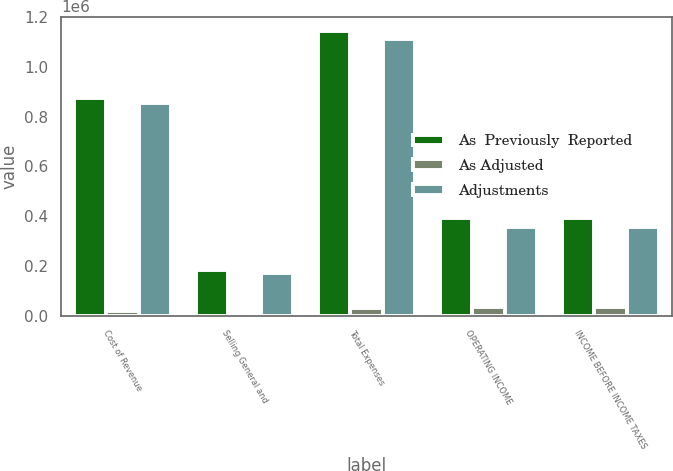Convert chart to OTSL. <chart><loc_0><loc_0><loc_500><loc_500><stacked_bar_chart><ecel><fcel>Cost of Revenue<fcel>Selling General and<fcel>Total Expenses<fcel>OPERATING INCOME<fcel>INCOME BEFORE INCOME TAXES<nl><fcel>As  Previously  Reported<fcel>873642<fcel>182146<fcel>1.14423e+06<fcel>392369<fcel>391024<nl><fcel>As Adjusted<fcel>20504<fcel>10436<fcel>30940<fcel>34866<fcel>34866<nl><fcel>Adjustments<fcel>853138<fcel>171710<fcel>1.11329e+06<fcel>357503<fcel>356158<nl></chart> 